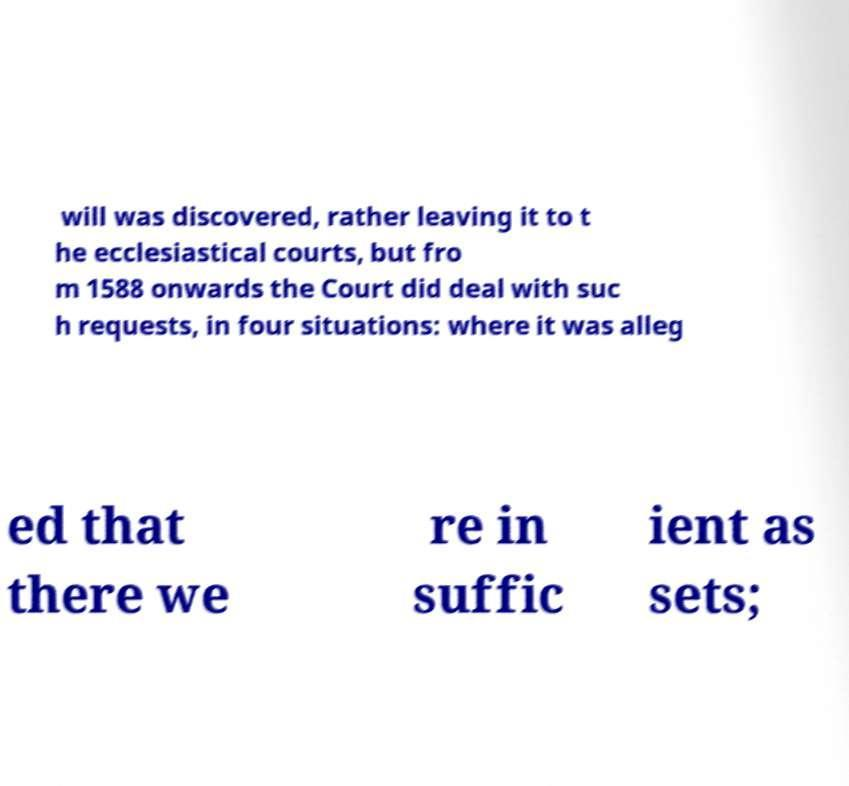For documentation purposes, I need the text within this image transcribed. Could you provide that? will was discovered, rather leaving it to t he ecclesiastical courts, but fro m 1588 onwards the Court did deal with suc h requests, in four situations: where it was alleg ed that there we re in suffic ient as sets; 